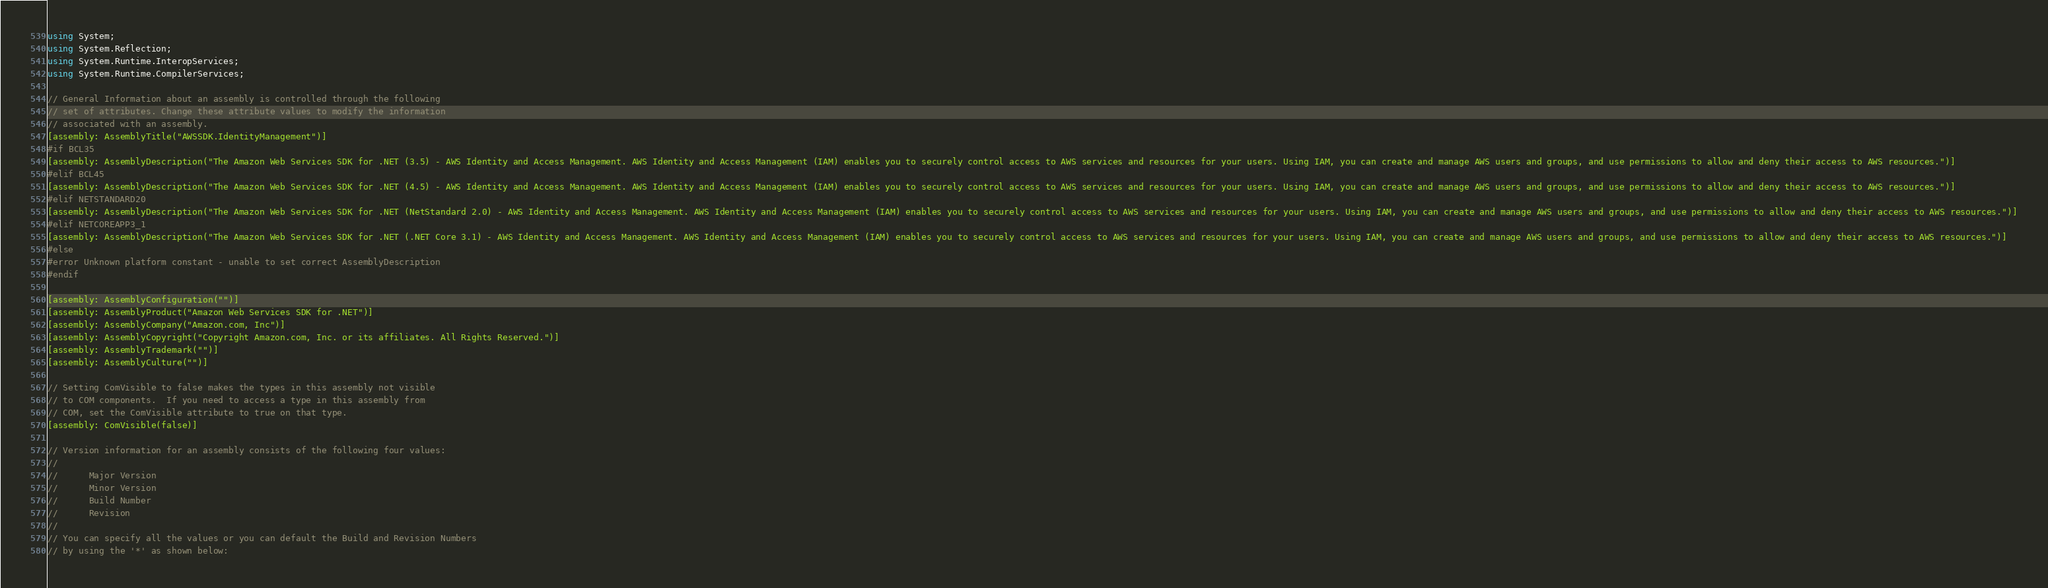Convert code to text. <code><loc_0><loc_0><loc_500><loc_500><_C#_>using System;
using System.Reflection;
using System.Runtime.InteropServices;
using System.Runtime.CompilerServices;

// General Information about an assembly is controlled through the following 
// set of attributes. Change these attribute values to modify the information
// associated with an assembly.
[assembly: AssemblyTitle("AWSSDK.IdentityManagement")]
#if BCL35
[assembly: AssemblyDescription("The Amazon Web Services SDK for .NET (3.5) - AWS Identity and Access Management. AWS Identity and Access Management (IAM) enables you to securely control access to AWS services and resources for your users. Using IAM, you can create and manage AWS users and groups, and use permissions to allow and deny their access to AWS resources.")]
#elif BCL45
[assembly: AssemblyDescription("The Amazon Web Services SDK for .NET (4.5) - AWS Identity and Access Management. AWS Identity and Access Management (IAM) enables you to securely control access to AWS services and resources for your users. Using IAM, you can create and manage AWS users and groups, and use permissions to allow and deny their access to AWS resources.")]
#elif NETSTANDARD20
[assembly: AssemblyDescription("The Amazon Web Services SDK for .NET (NetStandard 2.0) - AWS Identity and Access Management. AWS Identity and Access Management (IAM) enables you to securely control access to AWS services and resources for your users. Using IAM, you can create and manage AWS users and groups, and use permissions to allow and deny their access to AWS resources.")]
#elif NETCOREAPP3_1
[assembly: AssemblyDescription("The Amazon Web Services SDK for .NET (.NET Core 3.1) - AWS Identity and Access Management. AWS Identity and Access Management (IAM) enables you to securely control access to AWS services and resources for your users. Using IAM, you can create and manage AWS users and groups, and use permissions to allow and deny their access to AWS resources.")]
#else
#error Unknown platform constant - unable to set correct AssemblyDescription
#endif

[assembly: AssemblyConfiguration("")]
[assembly: AssemblyProduct("Amazon Web Services SDK for .NET")]
[assembly: AssemblyCompany("Amazon.com, Inc")]
[assembly: AssemblyCopyright("Copyright Amazon.com, Inc. or its affiliates. All Rights Reserved.")]
[assembly: AssemblyTrademark("")]
[assembly: AssemblyCulture("")]

// Setting ComVisible to false makes the types in this assembly not visible 
// to COM components.  If you need to access a type in this assembly from 
// COM, set the ComVisible attribute to true on that type.
[assembly: ComVisible(false)]

// Version information for an assembly consists of the following four values:
//
//      Major Version
//      Minor Version 
//      Build Number
//      Revision
//
// You can specify all the values or you can default the Build and Revision Numbers 
// by using the '*' as shown below:</code> 